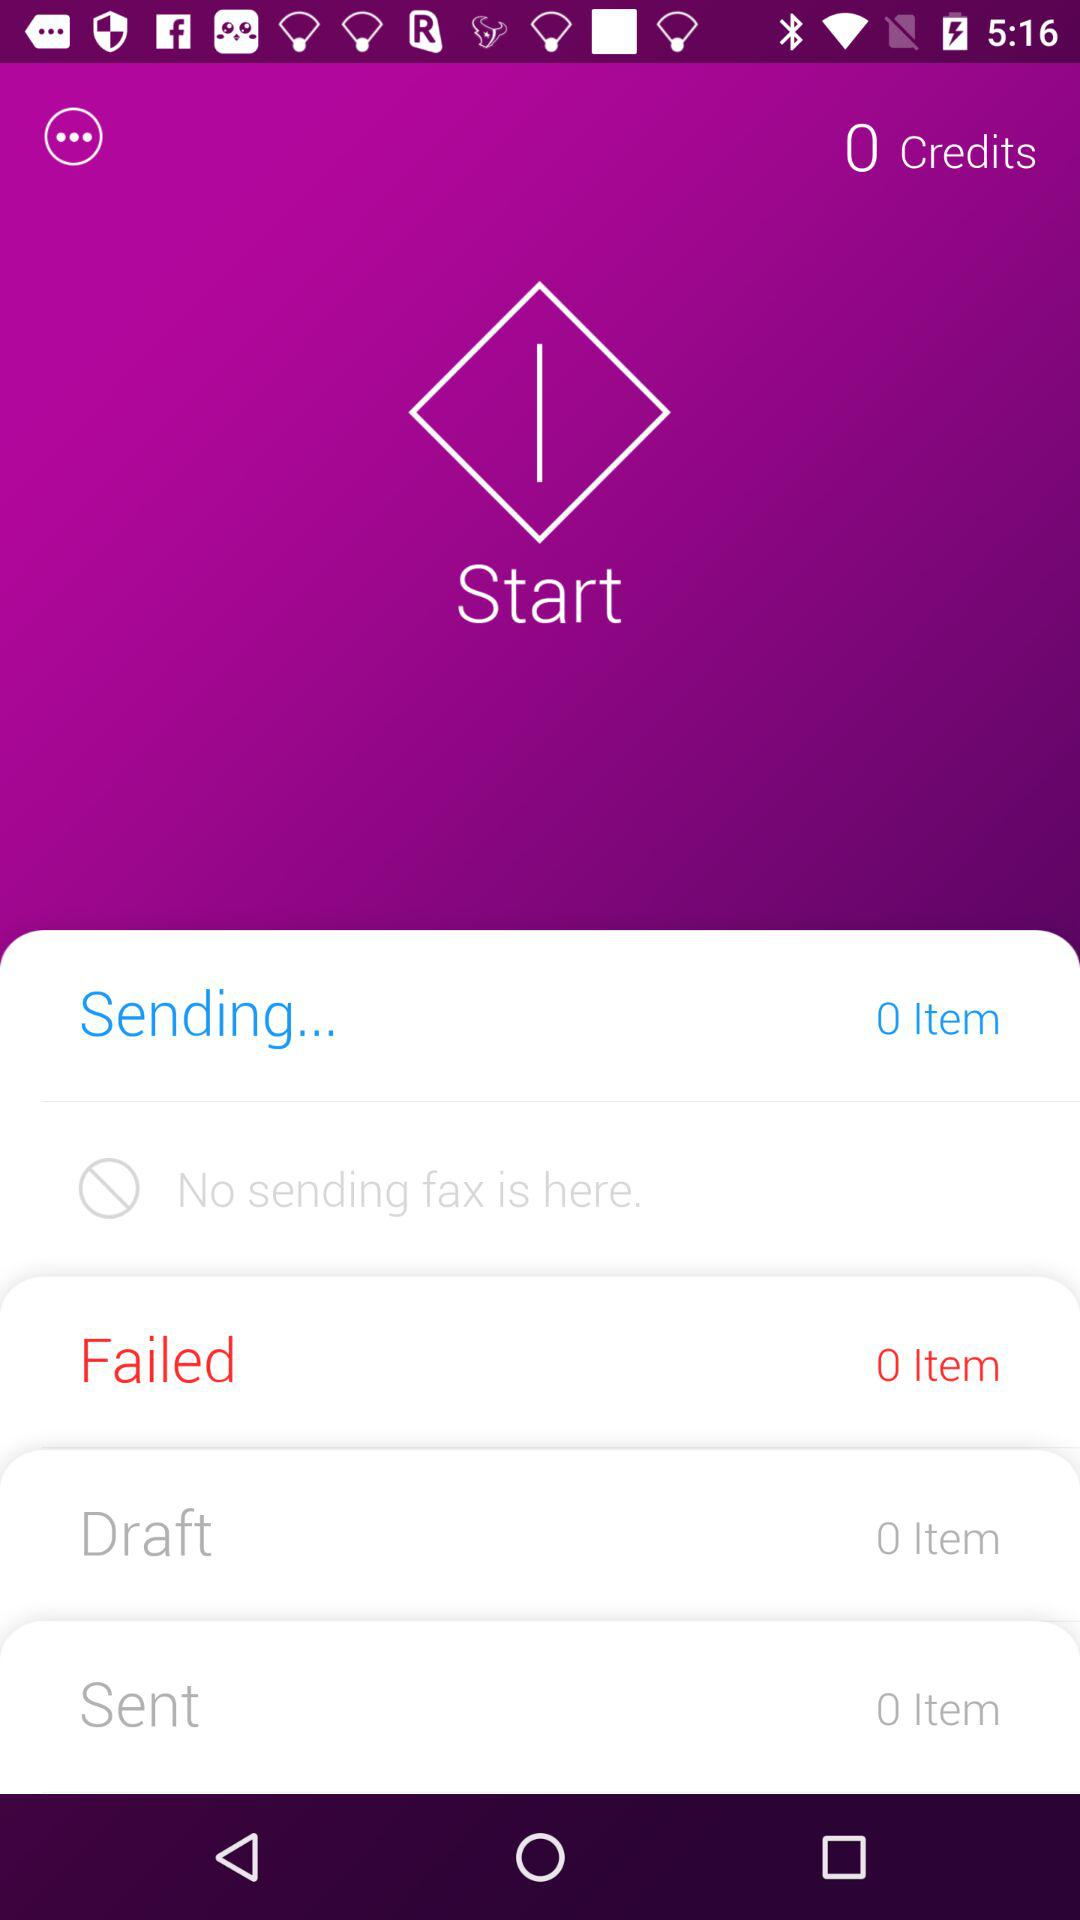What's the app called?
When the provided information is insufficient, respond with <no answer>. <no answer> 